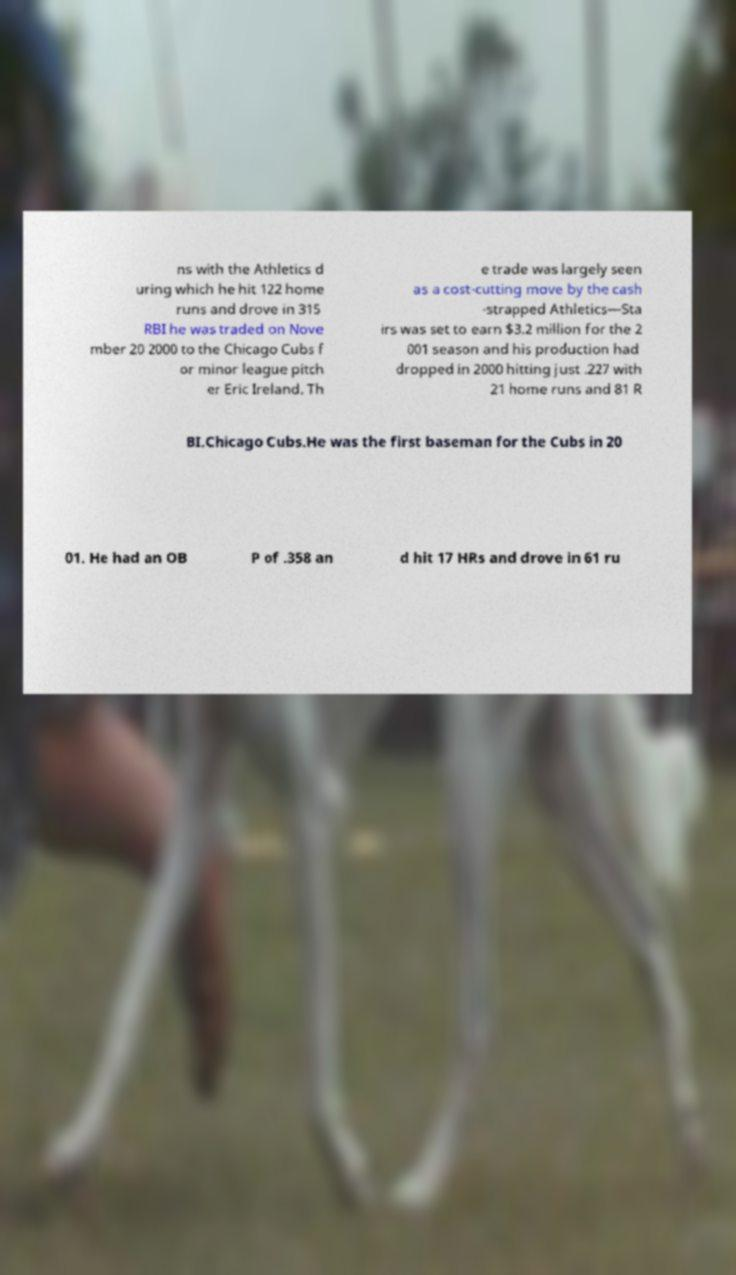What messages or text are displayed in this image? I need them in a readable, typed format. ns with the Athletics d uring which he hit 122 home runs and drove in 315 RBI he was traded on Nove mber 20 2000 to the Chicago Cubs f or minor league pitch er Eric Ireland. Th e trade was largely seen as a cost-cutting move by the cash -strapped Athletics—Sta irs was set to earn $3.2 million for the 2 001 season and his production had dropped in 2000 hitting just .227 with 21 home runs and 81 R BI.Chicago Cubs.He was the first baseman for the Cubs in 20 01. He had an OB P of .358 an d hit 17 HRs and drove in 61 ru 